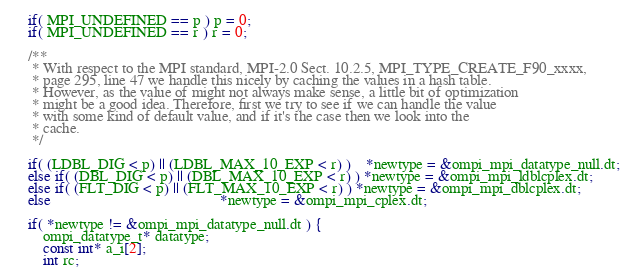<code> <loc_0><loc_0><loc_500><loc_500><_C_>    if( MPI_UNDEFINED == p ) p = 0;
    if( MPI_UNDEFINED == r ) r = 0;

    /**
     * With respect to the MPI standard, MPI-2.0 Sect. 10.2.5, MPI_TYPE_CREATE_F90_xxxx,
     * page 295, line 47 we handle this nicely by caching the values in a hash table.
     * However, as the value of might not always make sense, a little bit of optimization
     * might be a good idea. Therefore, first we try to see if we can handle the value
     * with some kind of default value, and if it's the case then we look into the
     * cache.
     */

    if( (LDBL_DIG < p) || (LDBL_MAX_10_EXP < r) )    *newtype = &ompi_mpi_datatype_null.dt;
    else if( (DBL_DIG < p) || (DBL_MAX_10_EXP < r) ) *newtype = &ompi_mpi_ldblcplex.dt;
    else if( (FLT_DIG < p) || (FLT_MAX_10_EXP < r) ) *newtype = &ompi_mpi_dblcplex.dt;
    else                                             *newtype = &ompi_mpi_cplex.dt;

    if( *newtype != &ompi_mpi_datatype_null.dt ) {
        ompi_datatype_t* datatype;
        const int* a_i[2];
        int rc;
</code> 